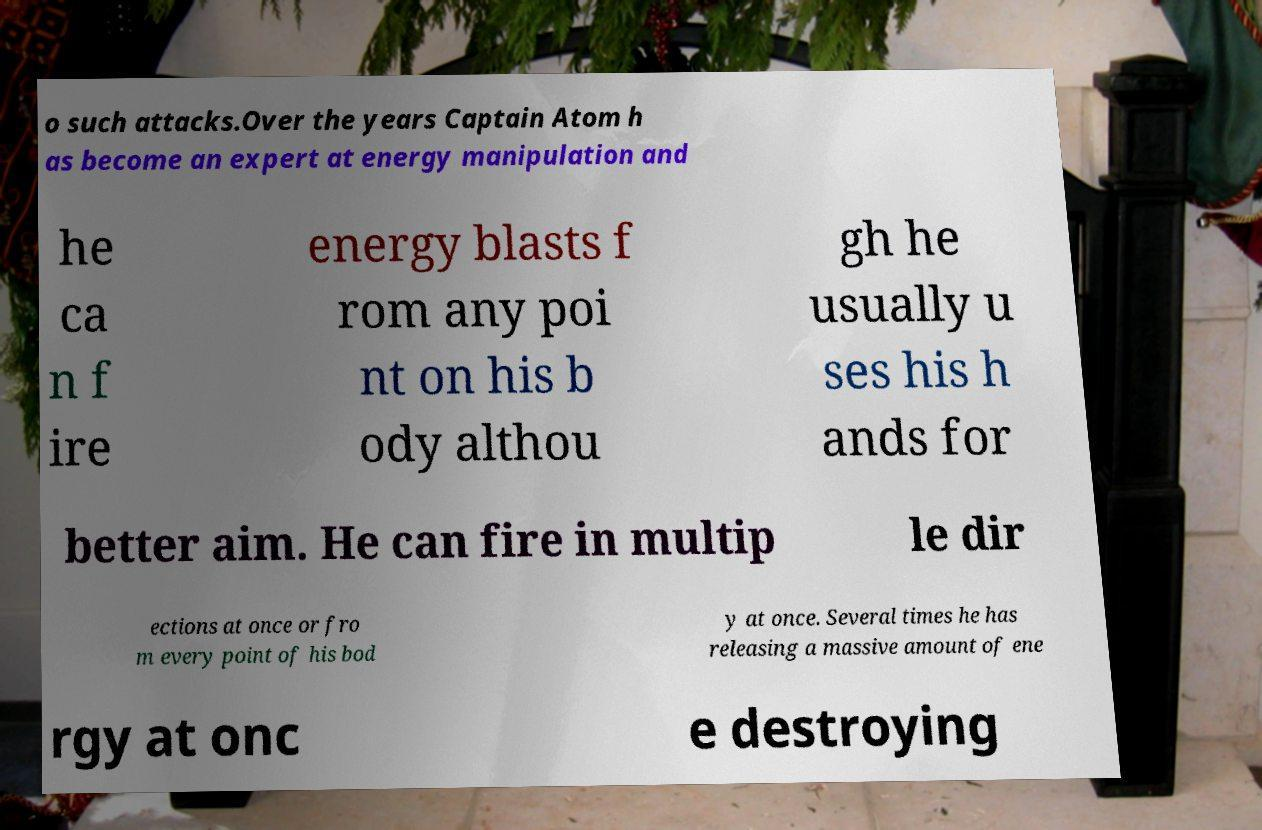For documentation purposes, I need the text within this image transcribed. Could you provide that? o such attacks.Over the years Captain Atom h as become an expert at energy manipulation and he ca n f ire energy blasts f rom any poi nt on his b ody althou gh he usually u ses his h ands for better aim. He can fire in multip le dir ections at once or fro m every point of his bod y at once. Several times he has releasing a massive amount of ene rgy at onc e destroying 